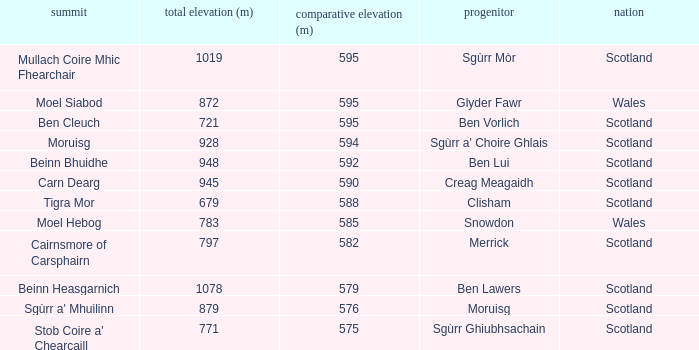What is the relative height of Scotland with Ben Vorlich as parent? 1.0. 